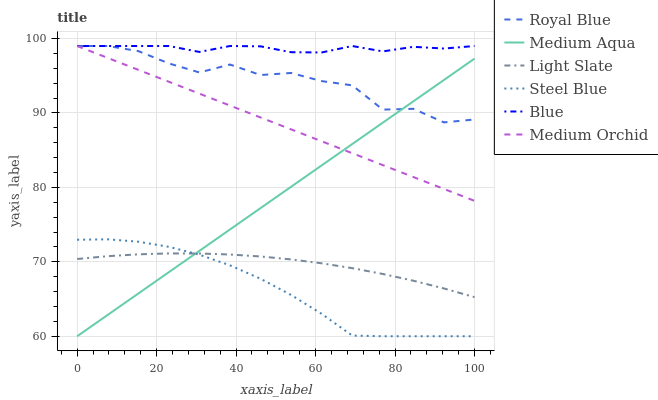Does Steel Blue have the minimum area under the curve?
Answer yes or no. Yes. Does Blue have the maximum area under the curve?
Answer yes or no. Yes. Does Light Slate have the minimum area under the curve?
Answer yes or no. No. Does Light Slate have the maximum area under the curve?
Answer yes or no. No. Is Medium Orchid the smoothest?
Answer yes or no. Yes. Is Royal Blue the roughest?
Answer yes or no. Yes. Is Light Slate the smoothest?
Answer yes or no. No. Is Light Slate the roughest?
Answer yes or no. No. Does Steel Blue have the lowest value?
Answer yes or no. Yes. Does Light Slate have the lowest value?
Answer yes or no. No. Does Royal Blue have the highest value?
Answer yes or no. Yes. Does Light Slate have the highest value?
Answer yes or no. No. Is Steel Blue less than Blue?
Answer yes or no. Yes. Is Medium Orchid greater than Light Slate?
Answer yes or no. Yes. Does Royal Blue intersect Blue?
Answer yes or no. Yes. Is Royal Blue less than Blue?
Answer yes or no. No. Is Royal Blue greater than Blue?
Answer yes or no. No. Does Steel Blue intersect Blue?
Answer yes or no. No. 